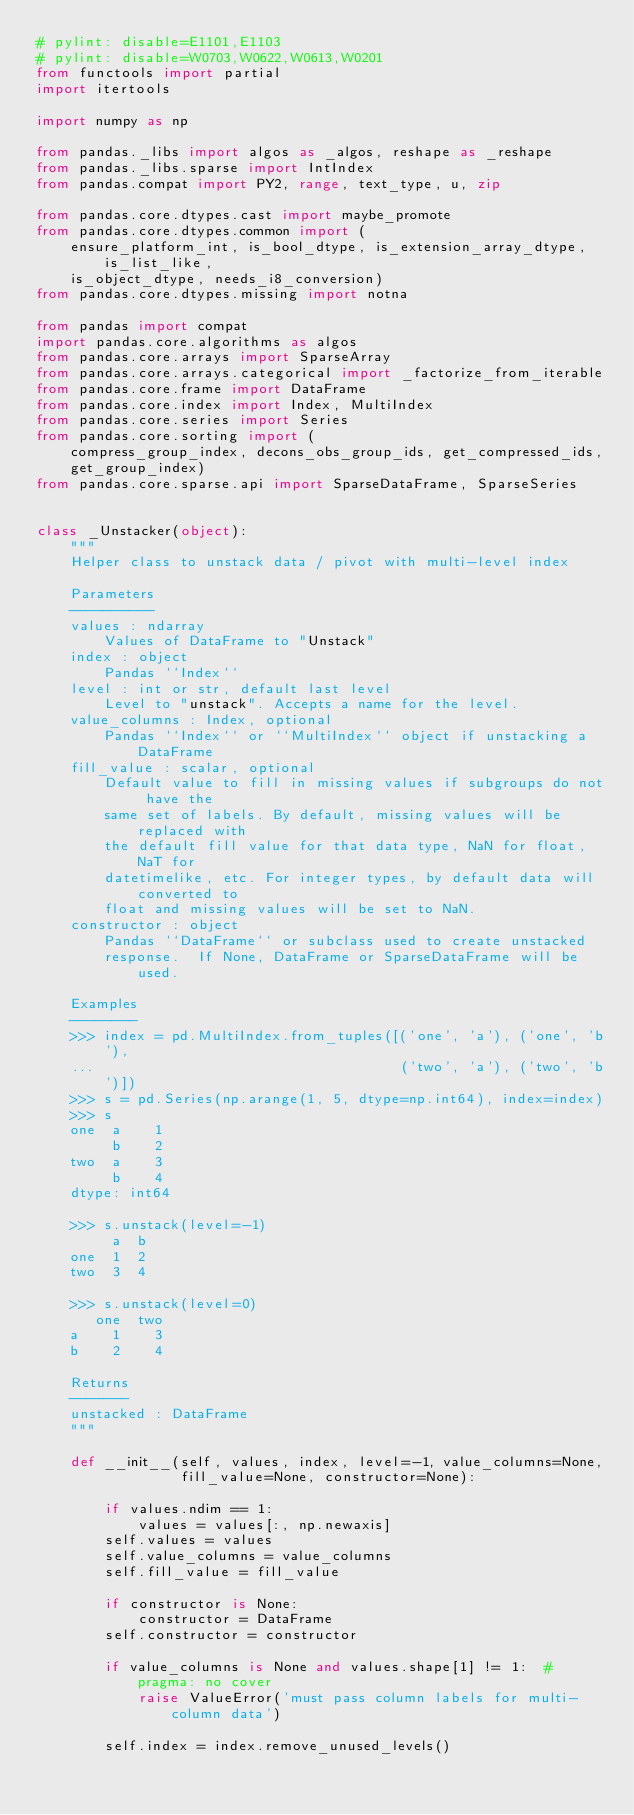<code> <loc_0><loc_0><loc_500><loc_500><_Python_># pylint: disable=E1101,E1103
# pylint: disable=W0703,W0622,W0613,W0201
from functools import partial
import itertools

import numpy as np

from pandas._libs import algos as _algos, reshape as _reshape
from pandas._libs.sparse import IntIndex
from pandas.compat import PY2, range, text_type, u, zip

from pandas.core.dtypes.cast import maybe_promote
from pandas.core.dtypes.common import (
    ensure_platform_int, is_bool_dtype, is_extension_array_dtype, is_list_like,
    is_object_dtype, needs_i8_conversion)
from pandas.core.dtypes.missing import notna

from pandas import compat
import pandas.core.algorithms as algos
from pandas.core.arrays import SparseArray
from pandas.core.arrays.categorical import _factorize_from_iterable
from pandas.core.frame import DataFrame
from pandas.core.index import Index, MultiIndex
from pandas.core.series import Series
from pandas.core.sorting import (
    compress_group_index, decons_obs_group_ids, get_compressed_ids,
    get_group_index)
from pandas.core.sparse.api import SparseDataFrame, SparseSeries


class _Unstacker(object):
    """
    Helper class to unstack data / pivot with multi-level index

    Parameters
    ----------
    values : ndarray
        Values of DataFrame to "Unstack"
    index : object
        Pandas ``Index``
    level : int or str, default last level
        Level to "unstack". Accepts a name for the level.
    value_columns : Index, optional
        Pandas ``Index`` or ``MultiIndex`` object if unstacking a DataFrame
    fill_value : scalar, optional
        Default value to fill in missing values if subgroups do not have the
        same set of labels. By default, missing values will be replaced with
        the default fill value for that data type, NaN for float, NaT for
        datetimelike, etc. For integer types, by default data will converted to
        float and missing values will be set to NaN.
    constructor : object
        Pandas ``DataFrame`` or subclass used to create unstacked
        response.  If None, DataFrame or SparseDataFrame will be used.

    Examples
    --------
    >>> index = pd.MultiIndex.from_tuples([('one', 'a'), ('one', 'b'),
    ...                                    ('two', 'a'), ('two', 'b')])
    >>> s = pd.Series(np.arange(1, 5, dtype=np.int64), index=index)
    >>> s
    one  a    1
         b    2
    two  a    3
         b    4
    dtype: int64

    >>> s.unstack(level=-1)
         a  b
    one  1  2
    two  3  4

    >>> s.unstack(level=0)
       one  two
    a    1    3
    b    2    4

    Returns
    -------
    unstacked : DataFrame
    """

    def __init__(self, values, index, level=-1, value_columns=None,
                 fill_value=None, constructor=None):

        if values.ndim == 1:
            values = values[:, np.newaxis]
        self.values = values
        self.value_columns = value_columns
        self.fill_value = fill_value

        if constructor is None:
            constructor = DataFrame
        self.constructor = constructor

        if value_columns is None and values.shape[1] != 1:  # pragma: no cover
            raise ValueError('must pass column labels for multi-column data')

        self.index = index.remove_unused_levels()
</code> 